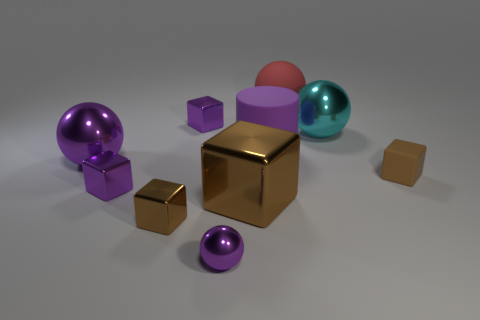The purple object that is the same size as the purple cylinder is what shape?
Your response must be concise. Sphere. How many other objects are the same color as the small matte object?
Offer a very short reply. 2. There is a brown object that is on the right side of the large cylinder; is its shape the same as the brown metallic object in front of the big brown thing?
Your response must be concise. Yes. How many things are either brown objects that are on the left side of the purple cylinder or tiny purple metallic cubes that are in front of the big cylinder?
Provide a short and direct response. 3. What number of other objects are there of the same material as the cyan sphere?
Your response must be concise. 6. Do the small brown block to the right of the cyan metallic ball and the big brown thing have the same material?
Your response must be concise. No. Is the number of tiny brown blocks that are left of the small sphere greater than the number of large rubber spheres that are to the right of the cyan shiny thing?
Your response must be concise. Yes. How many objects are either large spheres that are in front of the red thing or small purple spheres?
Your response must be concise. 3. What is the shape of the cyan thing that is the same material as the large block?
Your answer should be compact. Sphere. Are there any other things that are the same shape as the brown matte object?
Your answer should be compact. Yes. 